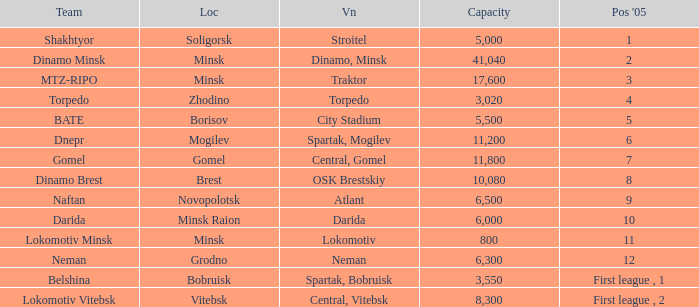Can you tell me the Capacity that has the Position in 2005 of 8? 10080.0. 